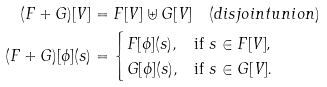Convert formula to latex. <formula><loc_0><loc_0><loc_500><loc_500>( F + G ) [ V ] & = F [ V ] \uplus G [ V ] \quad ( d i s j o i n t u n i o n ) \\ ( F + G ) [ \phi ] ( s ) & = \begin{cases} F [ \phi ] ( s ) , & \text {if $ s \in F[V] $,} \\ G [ \phi ] ( s ) , & \text {if $ s \in G[V]$.} \end{cases}</formula> 